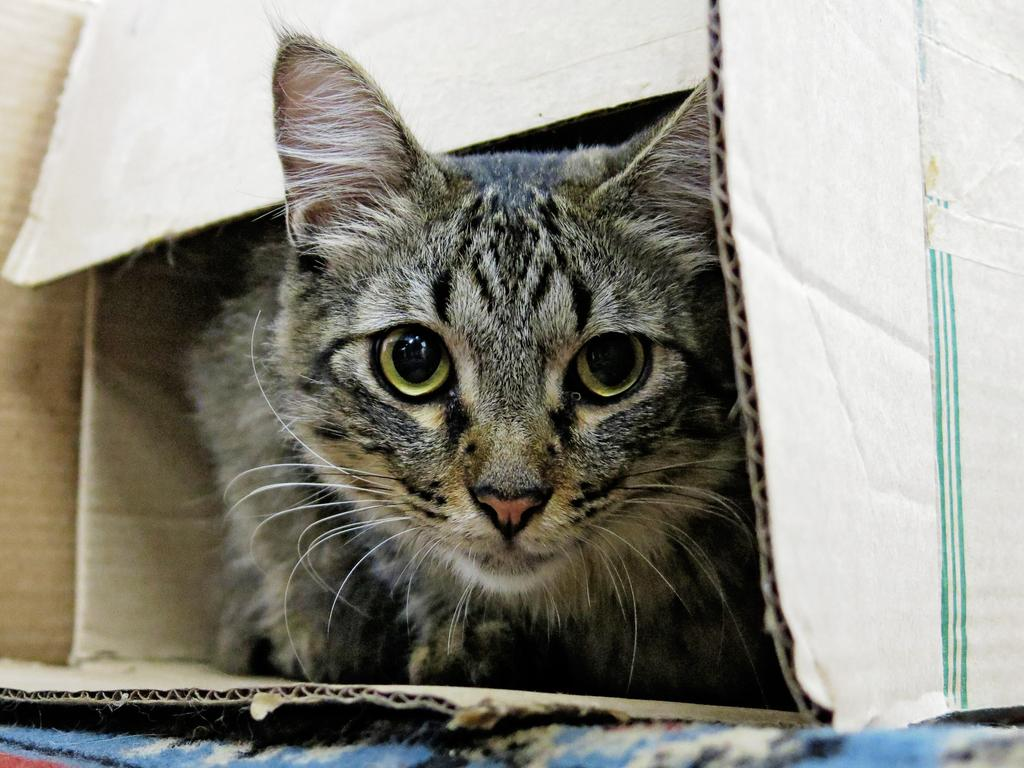What type of animal is in the image? There is a cat in the image. Where is the cat located in the image? The cat is in a box. How many oranges are on the seat next to the woman in the image? There is no woman or seat present in the image; it only features a cat in a box. 